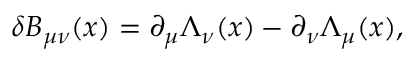Convert formula to latex. <formula><loc_0><loc_0><loc_500><loc_500>\delta B _ { \mu \nu } ( x ) = \partial _ { \mu } \Lambda _ { \nu } ( x ) - \partial _ { \nu } \Lambda _ { \mu } ( x ) ,</formula> 